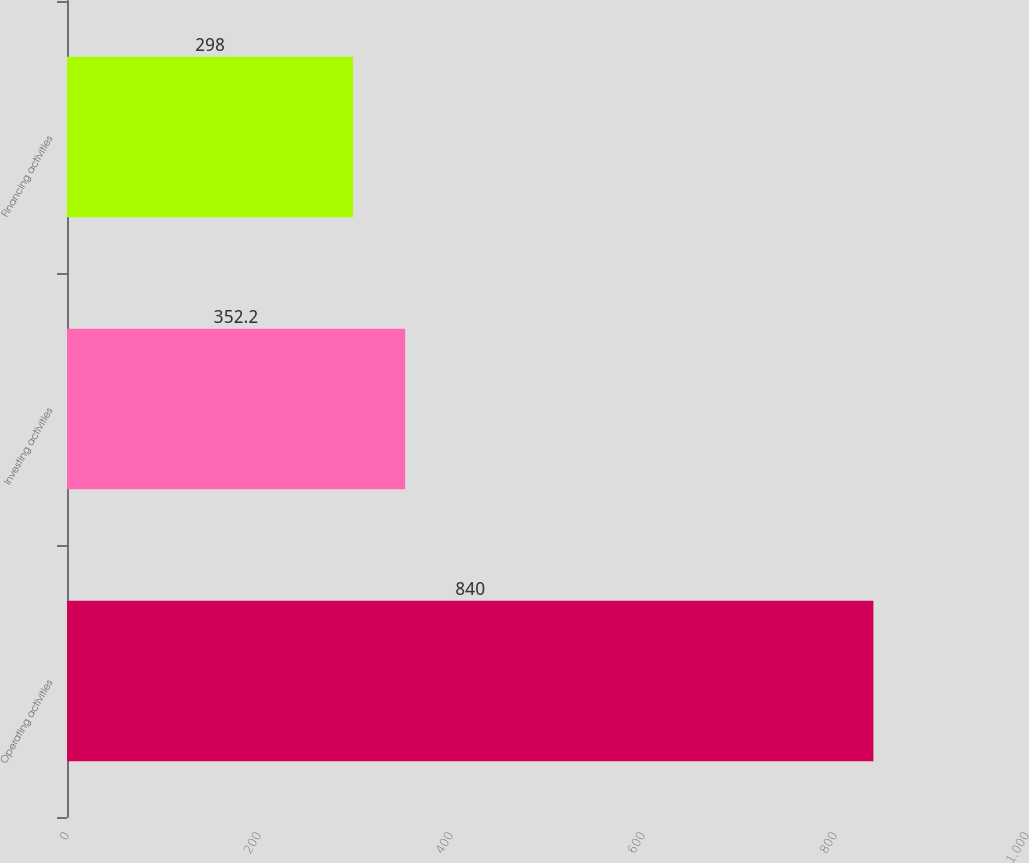Convert chart to OTSL. <chart><loc_0><loc_0><loc_500><loc_500><bar_chart><fcel>Operating activities<fcel>Investing activities<fcel>Financing activities<nl><fcel>840<fcel>352.2<fcel>298<nl></chart> 